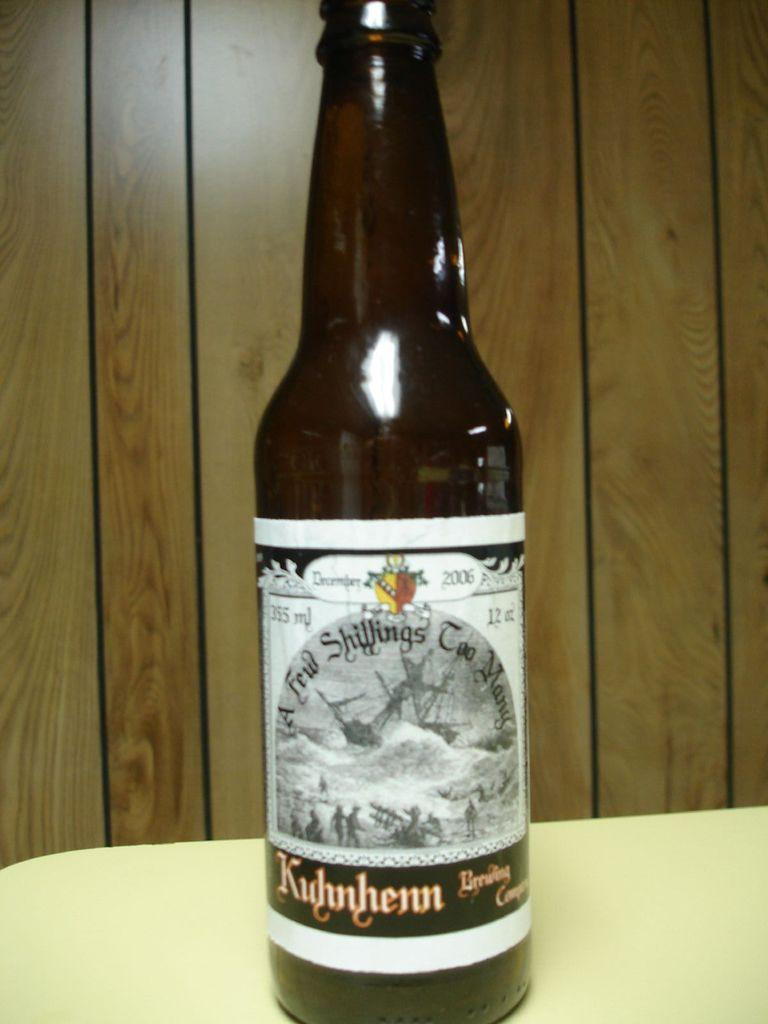Provide a one-sentence caption for the provided image. A bottle of beer from A Few Shillings Too Many. 